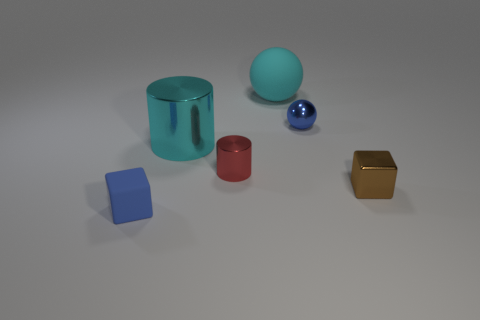Does the tiny cube on the left side of the blue metal sphere have the same material as the brown thing?
Your answer should be compact. No. There is a large cyan sphere that is left of the small brown cube; are there any metallic spheres behind it?
Keep it short and to the point. No. There is a large thing that is the same shape as the tiny blue shiny thing; what is its material?
Your response must be concise. Rubber. Is the number of large metal cylinders on the right side of the big cyan cylinder greater than the number of tiny things that are to the left of the tiny brown cube?
Provide a short and direct response. No. There is a cyan thing that is the same material as the small blue sphere; what is its shape?
Make the answer very short. Cylinder. Are there more metallic balls that are behind the blue metal sphere than big cyan spheres?
Offer a terse response. No. How many big objects have the same color as the matte sphere?
Keep it short and to the point. 1. How many other things are the same color as the tiny cylinder?
Offer a terse response. 0. Are there more big cyan metal things than blue objects?
Ensure brevity in your answer.  No. What is the cyan sphere made of?
Your answer should be very brief. Rubber. 